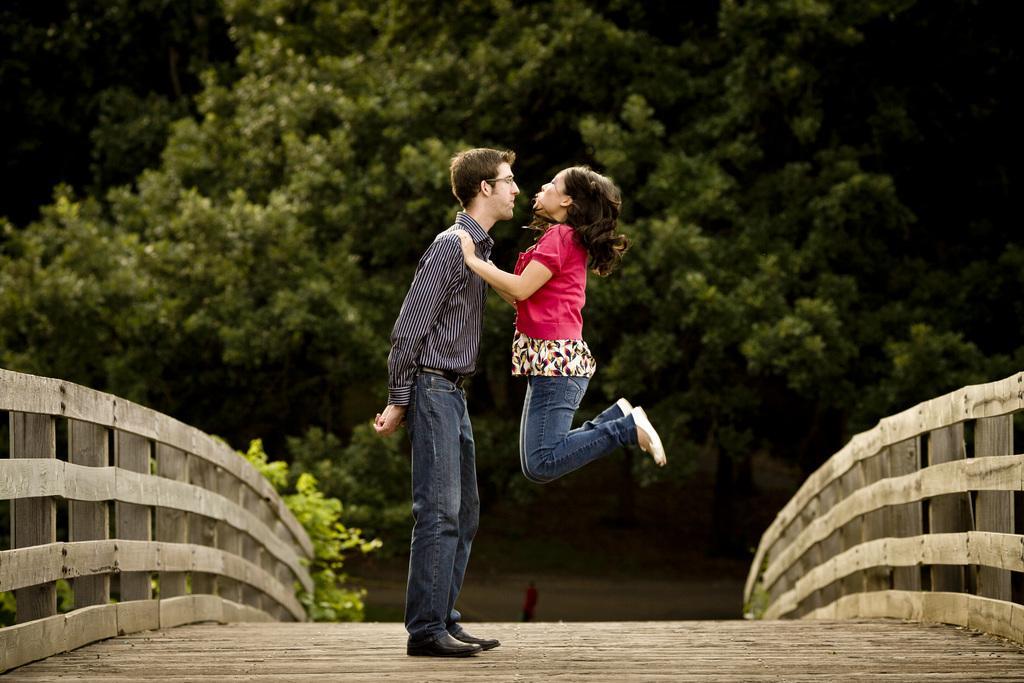Describe this image in one or two sentences. Middle of the image we can see two people. Right side of the image and left side of the image there are wooden railings. Background of the image we can see trees. 